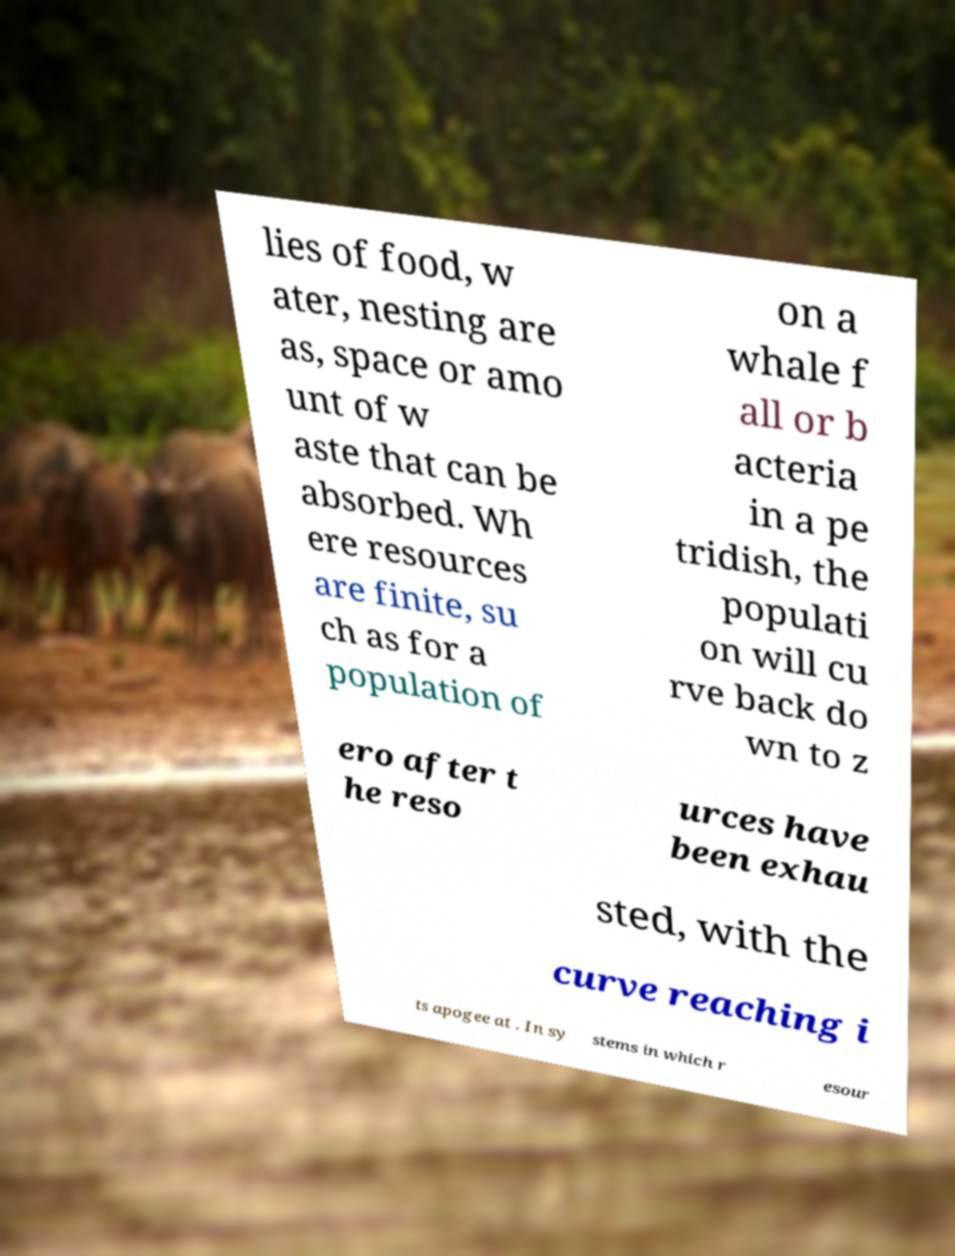I need the written content from this picture converted into text. Can you do that? lies of food, w ater, nesting are as, space or amo unt of w aste that can be absorbed. Wh ere resources are finite, su ch as for a population of on a whale f all or b acteria in a pe tridish, the populati on will cu rve back do wn to z ero after t he reso urces have been exhau sted, with the curve reaching i ts apogee at . In sy stems in which r esour 